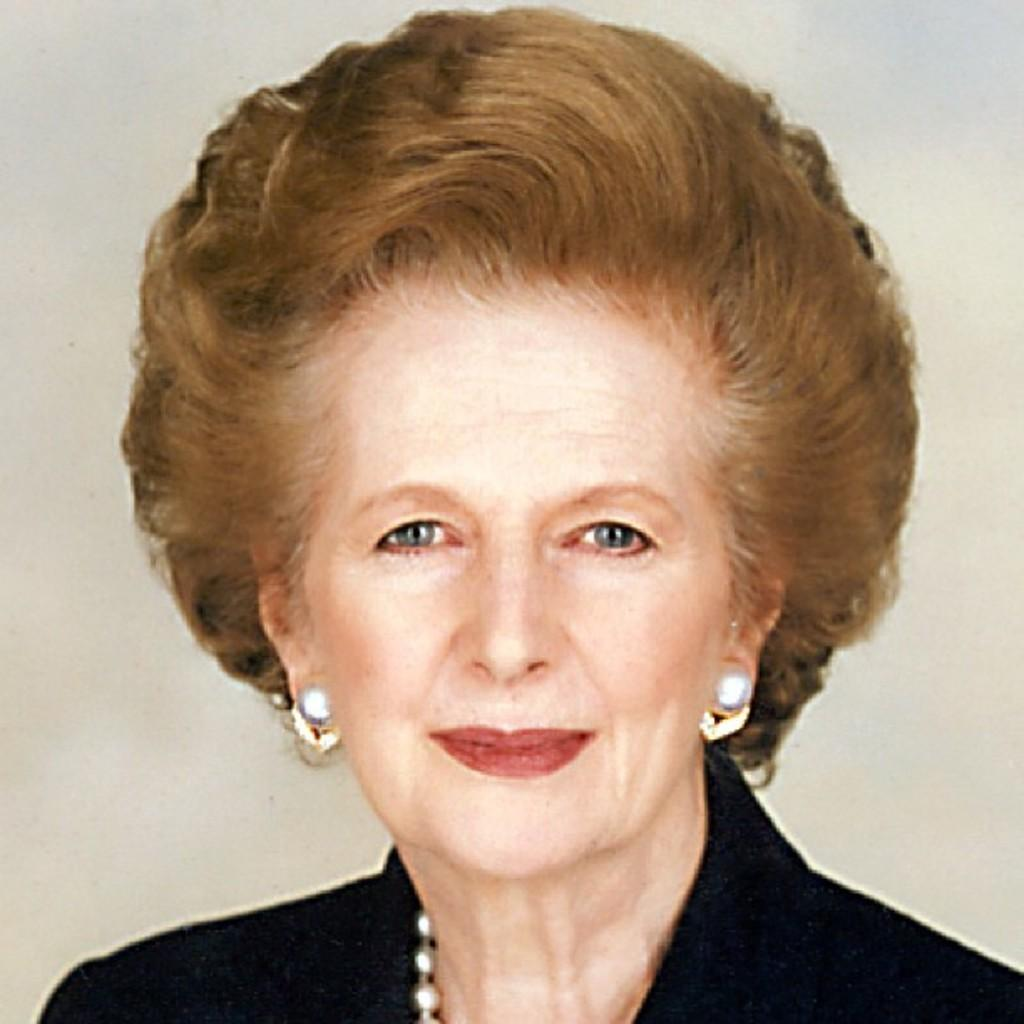Who is the main subject in the foreground of the image? There is a woman in the foreground of the image. What is the woman wearing? The woman is wearing a black dress. What color is the background of the image? The background of the image is cream-colored. How many cherries are on the island in the image? There is no island or cherries present in the image. What is the woman's temper like in the image? There is no information about the woman's temper in the image. 